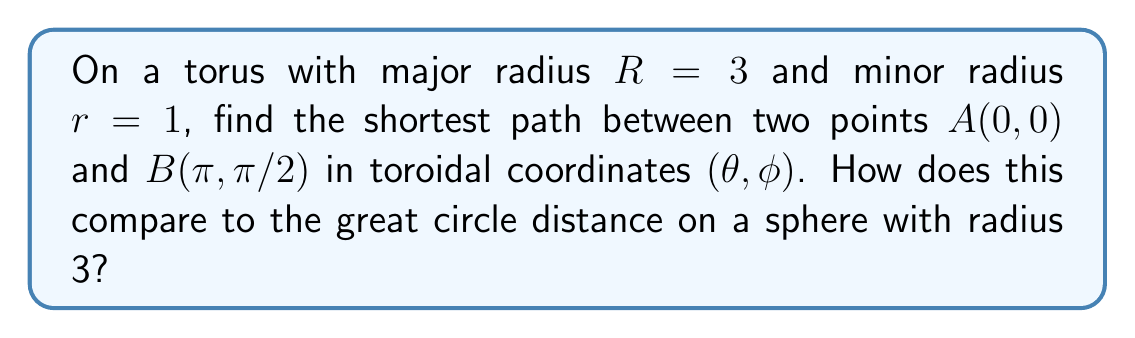Show me your answer to this math problem. Let's approach this step-by-step:

1) On a torus, the shortest path between two points is a geodesic. The equation for a geodesic on a torus is:

   $$\frac{d\phi}{d\theta} = \pm \sqrt{\frac{k^2}{(R + r\cos\phi)^2} - 1}$$

   where $k$ is a constant determined by the initial conditions.

2) For our points $A(0, 0)$ and $B(\pi, \pi/2)$, we need to solve:

   $$\int_0^\pi \frac{d\theta}{\sqrt{\frac{k^2}{(3 + \cos\phi)^2} - 1}} = \frac{\pi}{2}$$

3) This integral doesn't have a closed-form solution. We need to use numerical methods to find $k$ and then the length of the geodesic.

4) Using a numerical solver, we find $k \approx 3.1622$.

5) The length of the geodesic is given by:

   $$L = \int_0^\pi \sqrt{(R + r\cos\phi)^2 + r^2\left(\frac{d\phi}{d\theta}\right)^2} d\theta$$

6) Substituting our values and integrating numerically, we get:

   $$L \approx 3.3539$$

7) For comparison, on a sphere with radius 3, the great circle distance between two points separated by $(\pi, \pi/2)$ in spherical coordinates is:

   $$d = R \arccos(\sin\theta_1\sin\theta_2 + \cos\theta_1\cos\theta_2\cos(\phi_2-\phi_1))$$
   $$d = 3 \arccos(\sin(0)\sin(\pi/2) + \cos(0)\cos(\pi/2)\cos(\pi-0)) = 3\pi/2 \approx 4.7124$$

8) The shortest path on the torus is shorter than the great circle distance on a sphere of the same major radius.

[asy]
import graph3;
size(200);
currentprojection=perspective(6,3,2);
real R = 3, r = 1;
triple f(pair t) {return ((R+r*cos(t.y))*cos(t.x),(R+r*cos(t.y))*sin(t.x),r*sin(t.y));}
surface s=surface(f,(0,0),(2pi,2pi),8,8,Spline);
draw(s,paleblue);
dot(f((0,0)),red);
dot(f((pi,pi/2)),red);
draw(f((0,0))--f((pi,pi/2)),red);
[/asy]
Answer: $L \approx 3.3539$, shorter than sphere's great circle distance $\approx 4.7124$ 